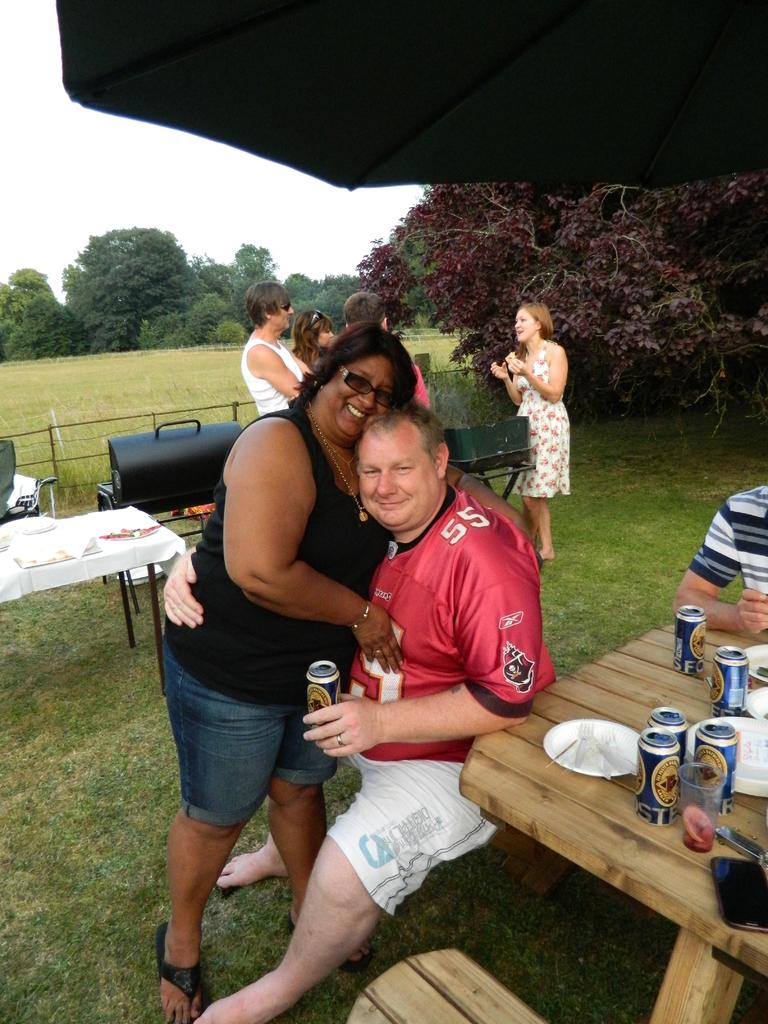<image>
Relay a brief, clear account of the picture shown. A man wearing the number 55 jersey is getting a hug. 